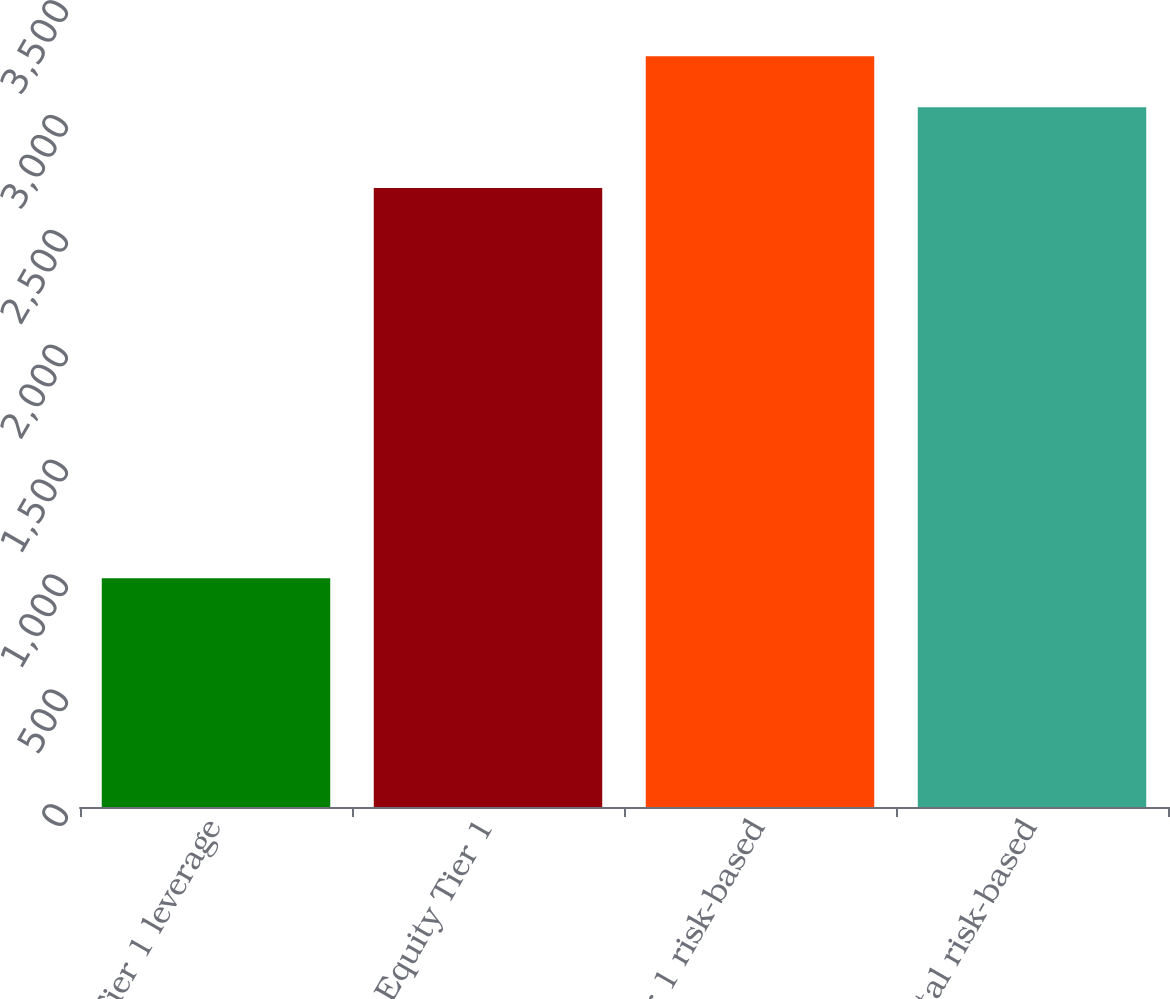Convert chart. <chart><loc_0><loc_0><loc_500><loc_500><bar_chart><fcel>Tier 1 leverage<fcel>Common Equity Tier 1<fcel>Tier 1 risk-based<fcel>Total risk-based<nl><fcel>996<fcel>2695<fcel>3268.4<fcel>3046<nl></chart> 